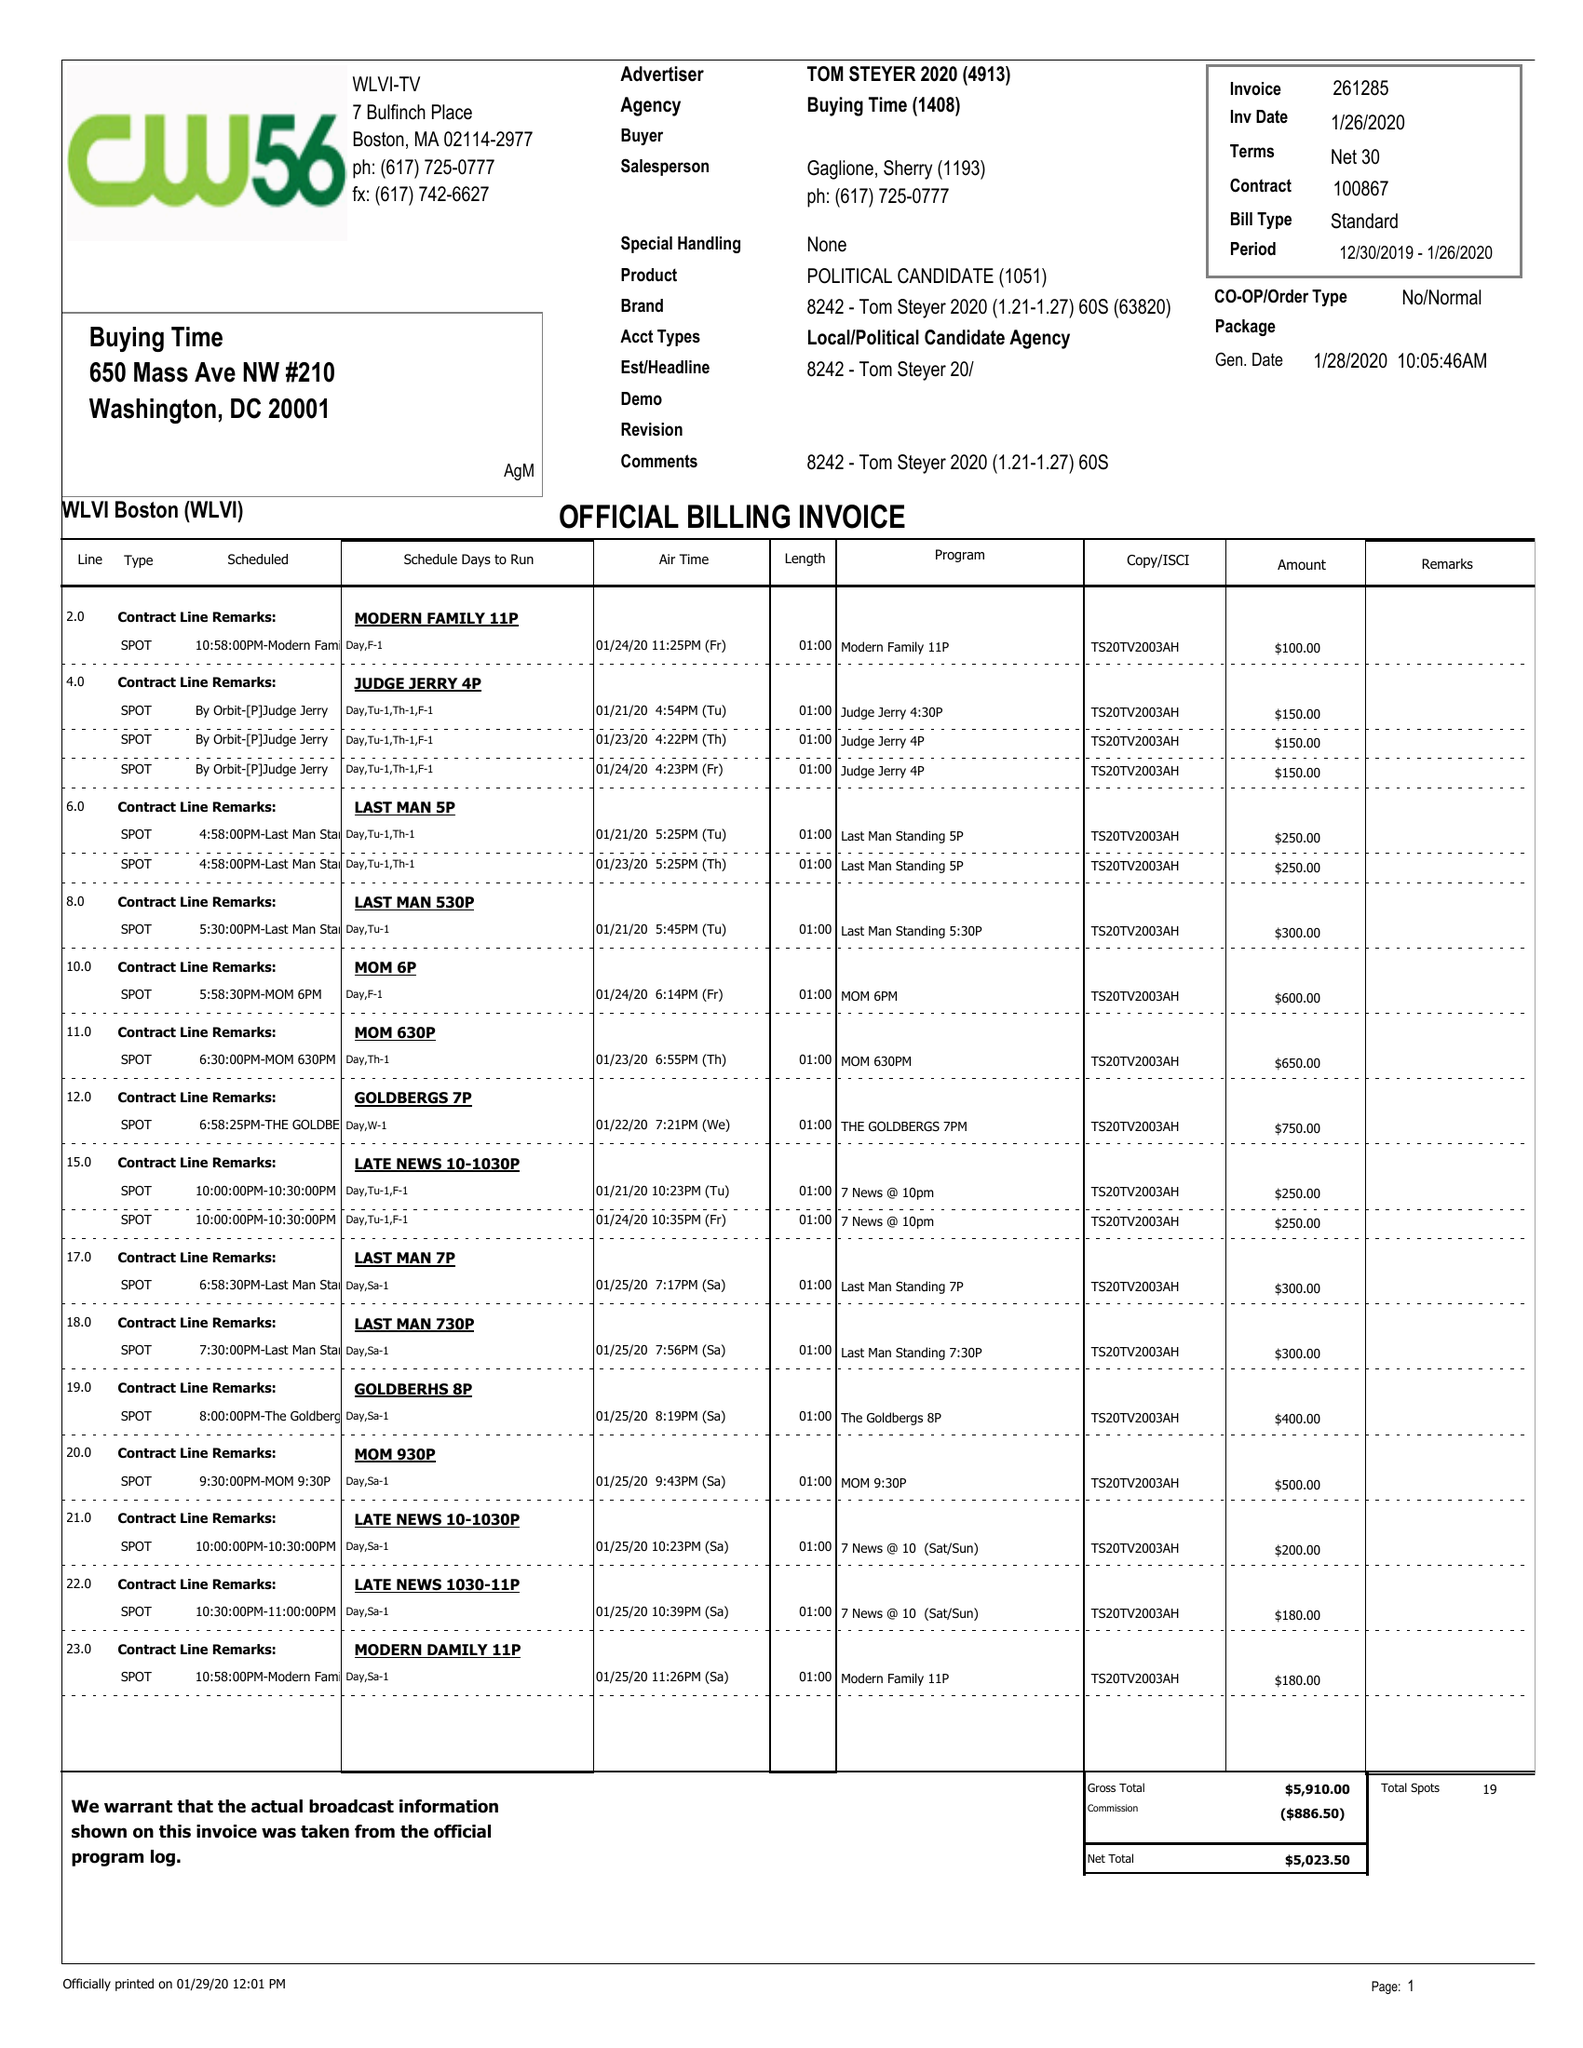What is the value for the flight_to?
Answer the question using a single word or phrase. 01/26/20 